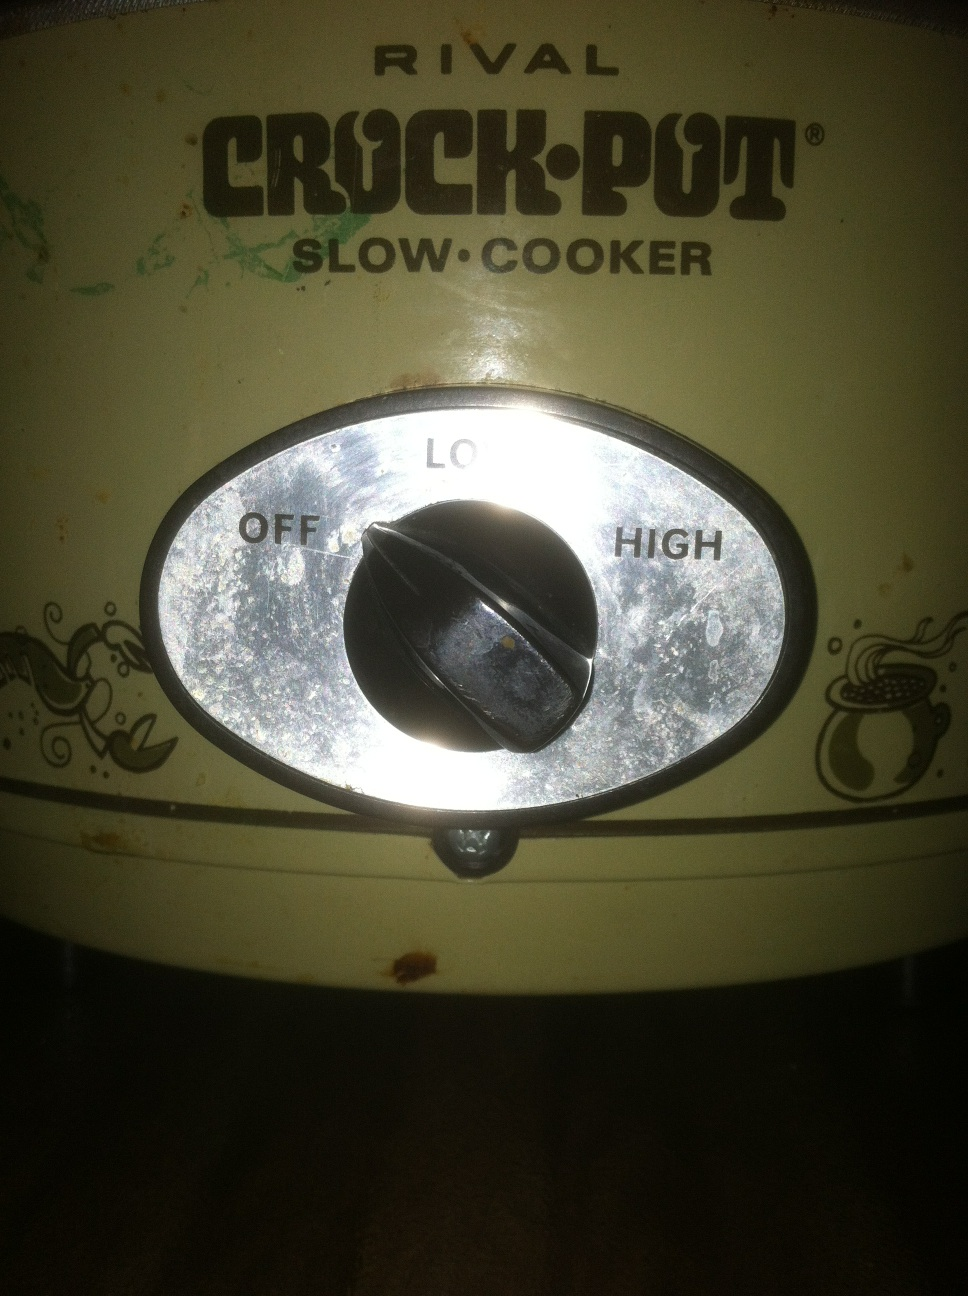What can you cook with this crock pot? You can cook a variety of dishes with this crock pot, including stews, soups, roasts, and even some desserts. Slow cookers are great for making meals that require long cooking times with minimal effort. Can this crock pot be used for baking bread? Yes, you can use a crock pot to bake bread. It won’t have the crustiness of oven-baked bread, but it will be soft and moist. Simply mix the bread dough, place it in a parchment-lined or greased crock pot, and set it to 'High'. It usually takes around 1.5 to 2.5 hours to bake. 